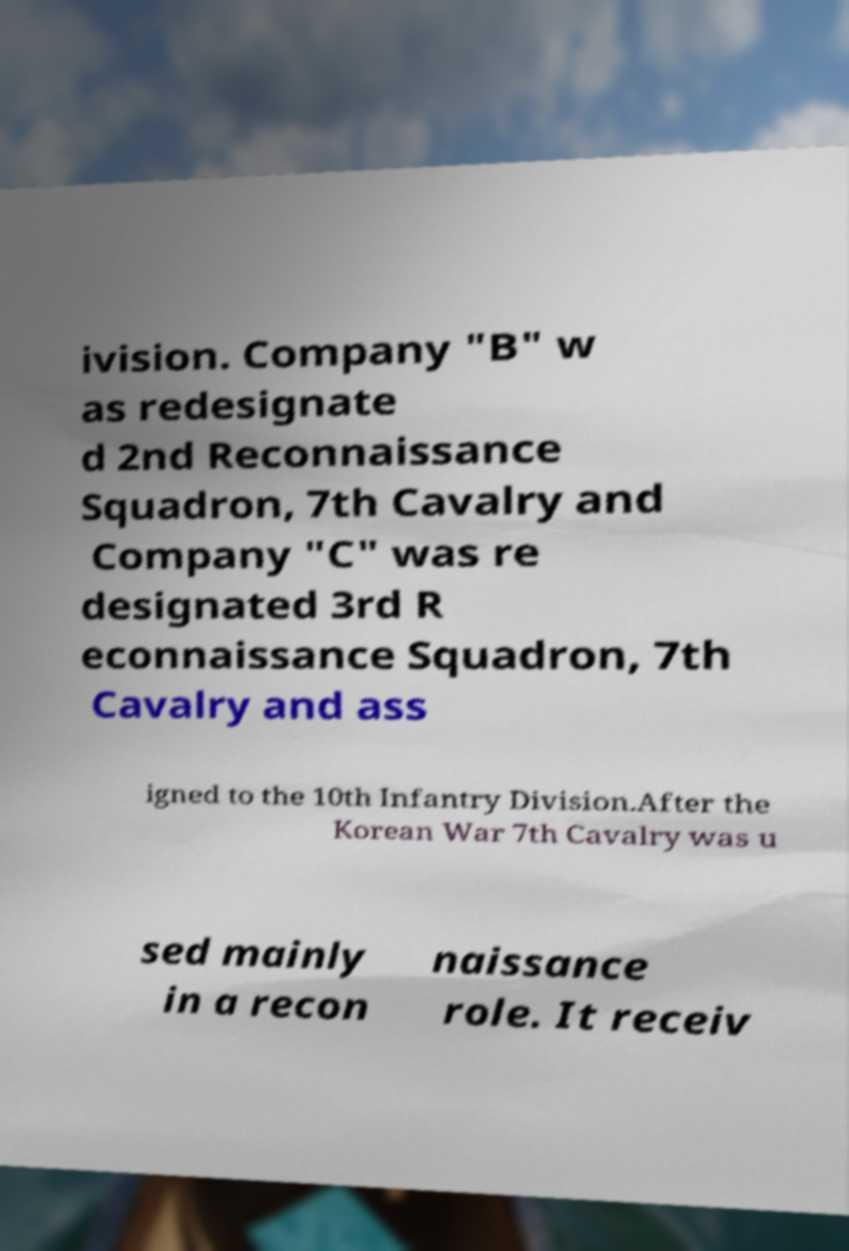Can you accurately transcribe the text from the provided image for me? ivision. Company "B" w as redesignate d 2nd Reconnaissance Squadron, 7th Cavalry and Company "C" was re designated 3rd R econnaissance Squadron, 7th Cavalry and ass igned to the 10th Infantry Division.After the Korean War 7th Cavalry was u sed mainly in a recon naissance role. It receiv 